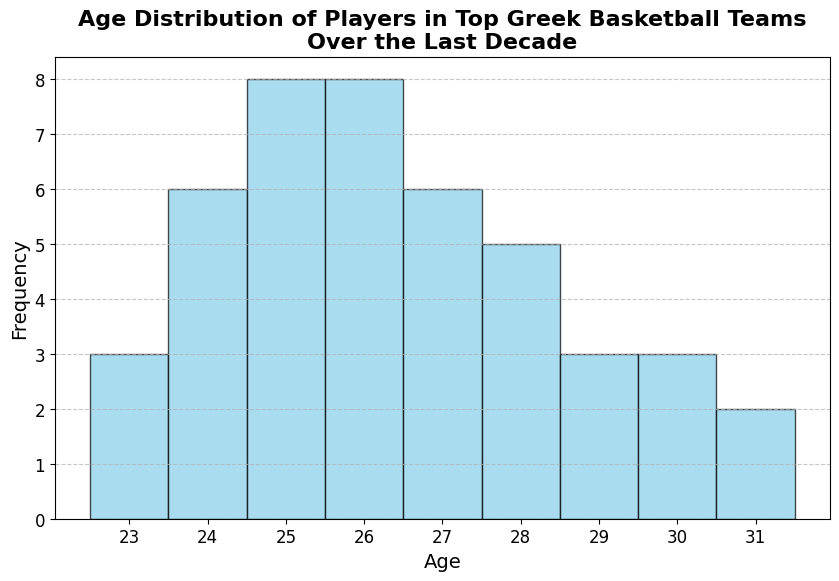How many players are aged 26? To find the number of players aged 26, count the bars in the histogram representing this age.
Answer: 10 How does the number of players aged 25 compare to those aged 29? Compare the height of the bars for ages 25 and 29. If one bar is taller, it indicates more players.
Answer: There are more players aged 25 Do we have more players aged 24 than aged 30? Observe the heights of the bars for ages 24 and 30 and compare them.
Answer: Yes, there are more players aged 24 What is the age range of the majority of the players? Look for the range where most of the high bars are concentrated in the histogram.
Answer: 24 to 28 What is the least common age among the players? Identify the shortest bar in the histogram, which indicates the age with the lowest frequency.
Answer: 31 Which age has the highest frequency? Find the tallest bar in the histogram as it shows the age with the highest count of players.
Answer: 25 What is the average age of the players shown in the histogram? Estimate the sum of all players' ages, then divide by the total number of players. In a histogram, one may calculate using bin heights and midpoints.
Answer: Approximately 26.2 Are players aged 27 more common than those aged 30? Compare the bars representing ages 27 and 30.
Answer: Yes, there are more players aged 27 What is the total number of players represented in the histogram? Sum up the heights of all bars in the histogram. Assuming each bar height equals the number of players for that age, summing them gives us the total number of players.
Answer: 40 Is there a clear peak in the ages, or is the distribution more uniform? Observe the overall shape of the histogram. A clear peak would show as one prominent bar or adjacent bars, whereas a uniform distribution would have bars of similar height.
Answer: Clear peak at age 25 